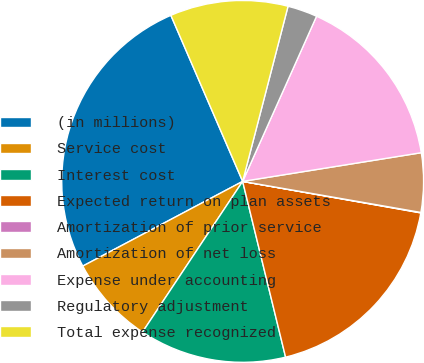Convert chart to OTSL. <chart><loc_0><loc_0><loc_500><loc_500><pie_chart><fcel>(in millions)<fcel>Service cost<fcel>Interest cost<fcel>Expected return on plan assets<fcel>Amortization of prior service<fcel>Amortization of net loss<fcel>Expense under accounting<fcel>Regulatory adjustment<fcel>Total expense recognized<nl><fcel>26.26%<fcel>7.91%<fcel>13.15%<fcel>18.4%<fcel>0.04%<fcel>5.28%<fcel>15.77%<fcel>2.66%<fcel>10.53%<nl></chart> 